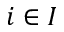Convert formula to latex. <formula><loc_0><loc_0><loc_500><loc_500>i \in I</formula> 